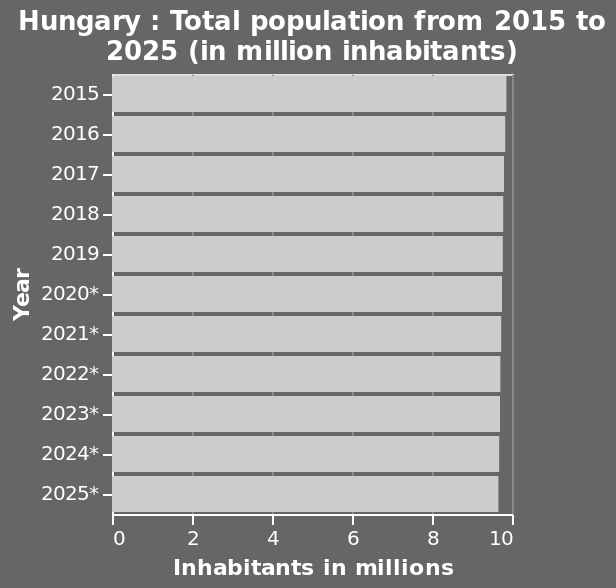<image>
What is the unit of measurement for the population values? The unit of measurement for the population values is million inhabitants. Is the population of Hungary expected to grow or decline between 2015 and 2025? The population of Hungary is expected to decline between 2015 and 2025. What trend does the population of Hungary show from 2015 to 2025? The population of Hungary shows a trend of gentle decline from 2015 to 2025. 